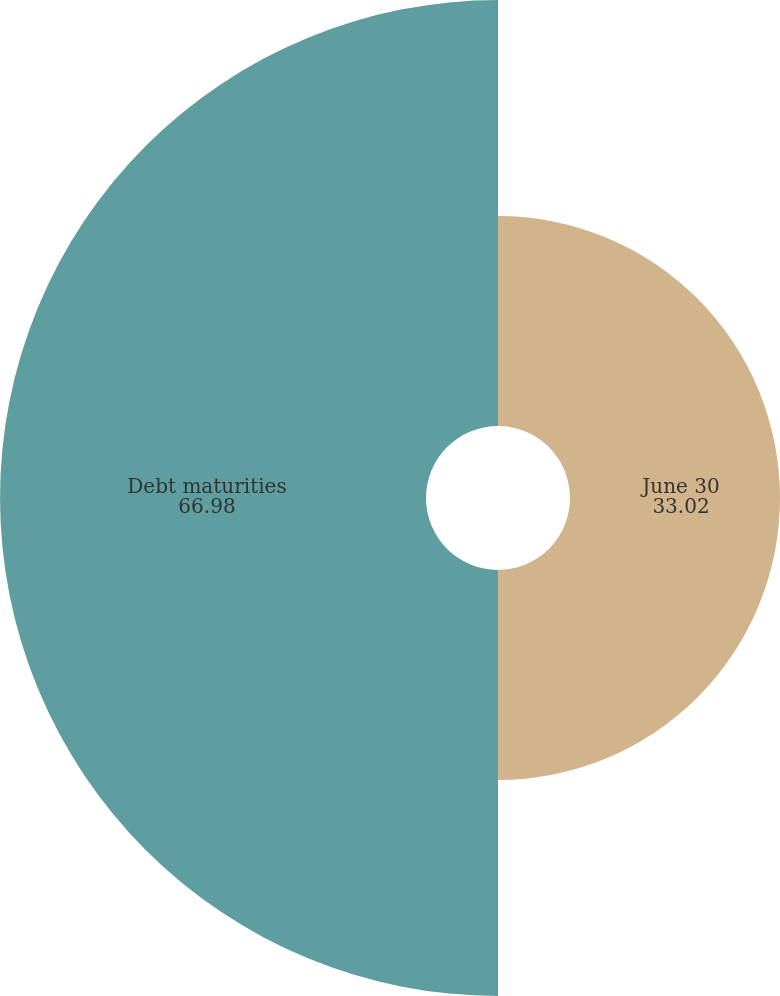Convert chart. <chart><loc_0><loc_0><loc_500><loc_500><pie_chart><fcel>June 30<fcel>Debt maturities<nl><fcel>33.02%<fcel>66.98%<nl></chart> 